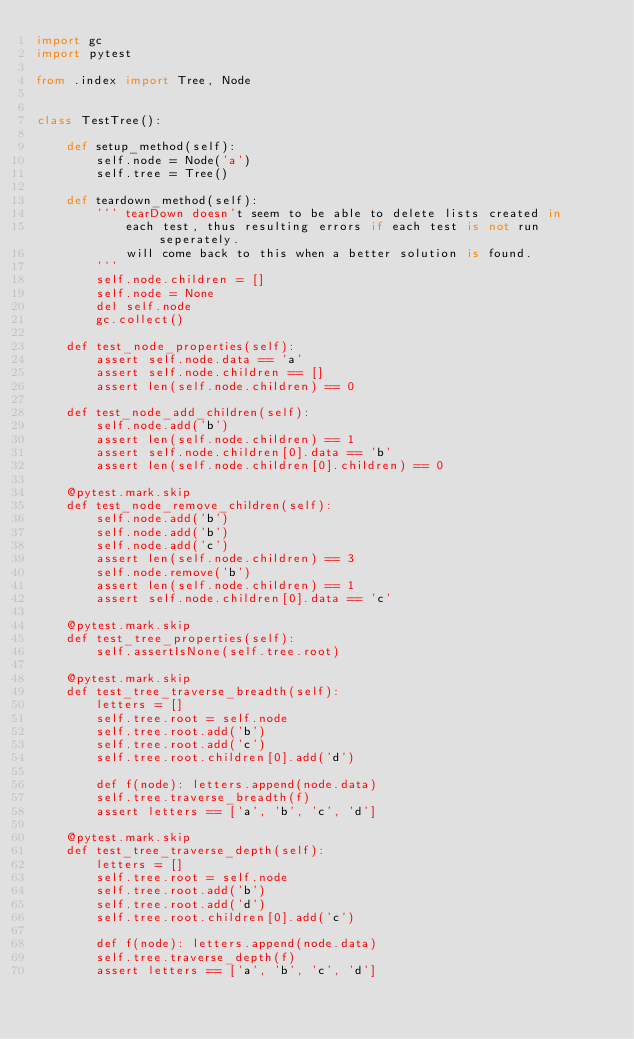Convert code to text. <code><loc_0><loc_0><loc_500><loc_500><_Python_>import gc
import pytest

from .index import Tree, Node


class TestTree():

    def setup_method(self):
        self.node = Node('a')
        self.tree = Tree()

    def teardown_method(self):
        ''' tearDown doesn't seem to be able to delete lists created in
            each test, thus resulting errors if each test is not run seperately.
            will come back to this when a better solution is found.
        '''
        self.node.children = []
        self.node = None
        del self.node
        gc.collect()

    def test_node_properties(self):
        assert self.node.data == 'a'
        assert self.node.children == []
        assert len(self.node.children) == 0

    def test_node_add_children(self):
        self.node.add('b')
        assert len(self.node.children) == 1
        assert self.node.children[0].data == 'b'
        assert len(self.node.children[0].children) == 0

    @pytest.mark.skip
    def test_node_remove_children(self):
        self.node.add('b')
        self.node.add('b')
        self.node.add('c')
        assert len(self.node.children) == 3
        self.node.remove('b')
        assert len(self.node.children) == 1
        assert self.node.children[0].data == 'c'

    @pytest.mark.skip
    def test_tree_properties(self):
        self.assertIsNone(self.tree.root)

    @pytest.mark.skip
    def test_tree_traverse_breadth(self):
        letters = []
        self.tree.root = self.node
        self.tree.root.add('b')
        self.tree.root.add('c')
        self.tree.root.children[0].add('d')

        def f(node): letters.append(node.data)
        self.tree.traverse_breadth(f)
        assert letters == ['a', 'b', 'c', 'd']

    @pytest.mark.skip
    def test_tree_traverse_depth(self):
        letters = []
        self.tree.root = self.node
        self.tree.root.add('b')
        self.tree.root.add('d')
        self.tree.root.children[0].add('c')

        def f(node): letters.append(node.data)
        self.tree.traverse_depth(f)
        assert letters == ['a', 'b', 'c', 'd']
</code> 